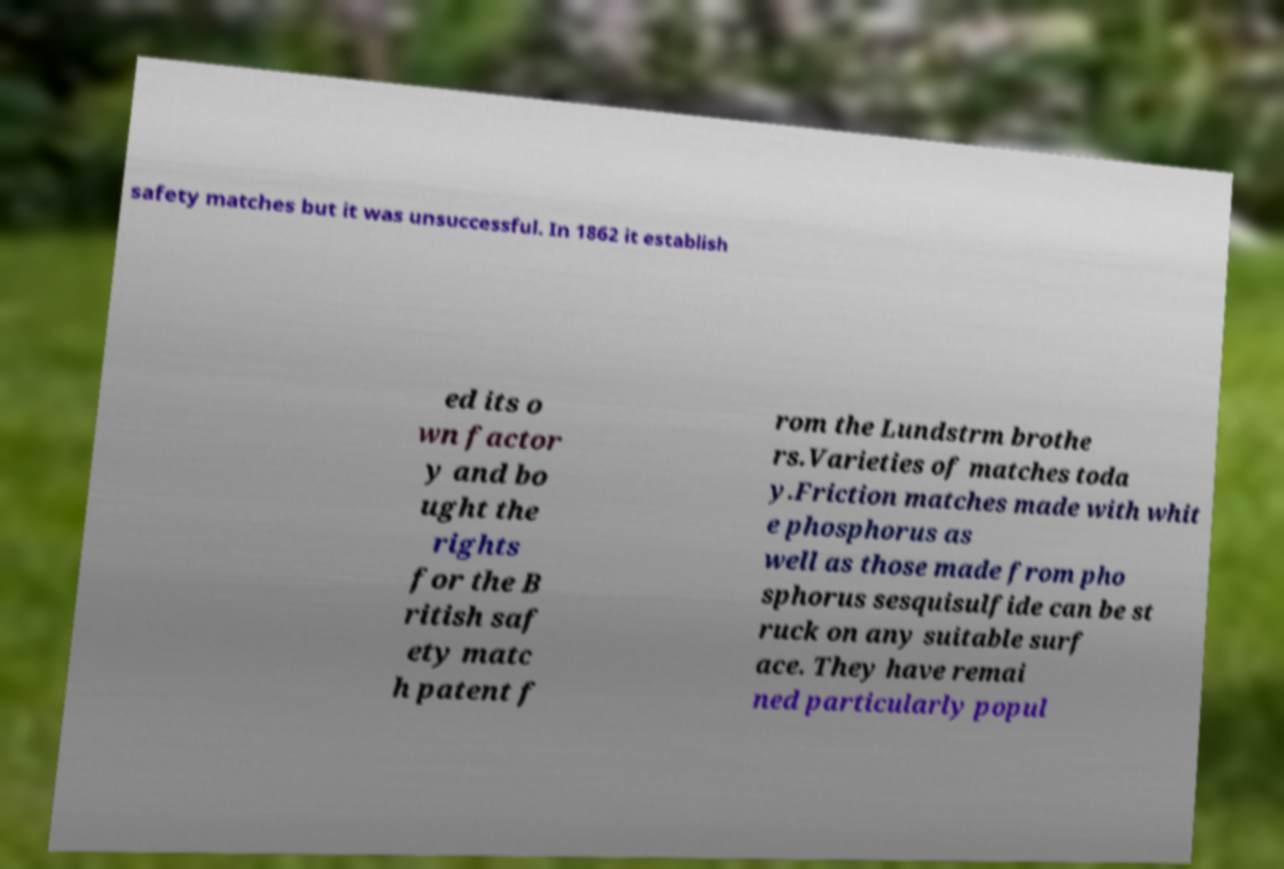Could you extract and type out the text from this image? safety matches but it was unsuccessful. In 1862 it establish ed its o wn factor y and bo ught the rights for the B ritish saf ety matc h patent f rom the Lundstrm brothe rs.Varieties of matches toda y.Friction matches made with whit e phosphorus as well as those made from pho sphorus sesquisulfide can be st ruck on any suitable surf ace. They have remai ned particularly popul 